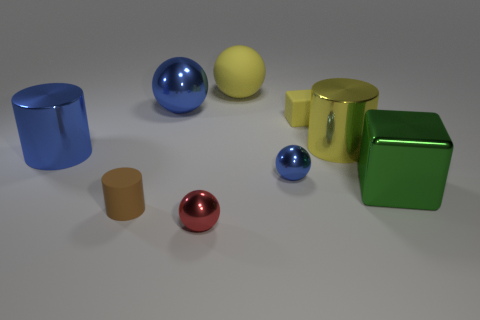What is the color of the rubber sphere that is the same size as the yellow metallic thing?
Ensure brevity in your answer.  Yellow. Is there anything else that has the same shape as the red object?
Keep it short and to the point. Yes. There is another small thing that is the same shape as the small blue object; what color is it?
Ensure brevity in your answer.  Red. How many things are either tiny cyan rubber cylinders or cylinders on the right side of the small cylinder?
Offer a terse response. 1. Are there fewer big metal cylinders right of the yellow cylinder than small gray blocks?
Your response must be concise. No. There is a blue shiny sphere that is behind the block to the left of the shiny object that is to the right of the yellow shiny cylinder; what size is it?
Provide a succinct answer. Large. There is a sphere that is left of the big yellow rubber sphere and behind the tiny yellow matte cube; what color is it?
Ensure brevity in your answer.  Blue. What number of large blue balls are there?
Provide a succinct answer. 1. Is there anything else that has the same size as the green cube?
Offer a very short reply. Yes. Do the small block and the large cube have the same material?
Your answer should be compact. No. 